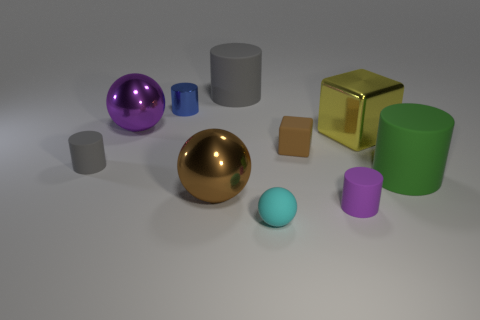How many metallic objects have the same color as the small block? Upon reviewing the image, I can confirm that there is 1 metallic object that matches the color of the small block, which is a golden hue. It's the cube-shaped object. 